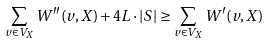<formula> <loc_0><loc_0><loc_500><loc_500>\sum _ { v \in V _ { X } } W ^ { \prime \prime } ( v , X ) + 4 L \cdot | S | \geq \sum _ { v \in V _ { X } } W ^ { \prime } ( v , X )</formula> 